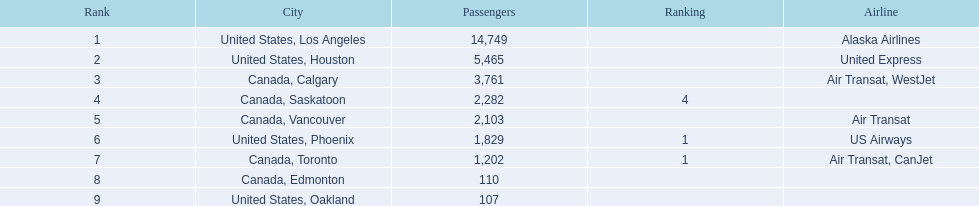Can you provide the total number of passengers? 14,749, 5,465, 3,761, 2,282, 2,103, 1,829, 1,202, 110, 107. Among them, how many were traveling to los angeles? 14,749. When combined with another destination, which one gets closest to a total of 19,000 passengers? Canada, Calgary. 